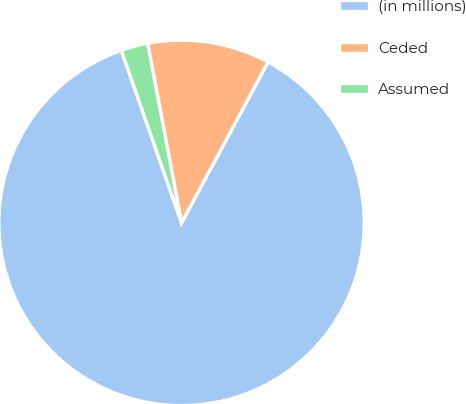Convert chart. <chart><loc_0><loc_0><loc_500><loc_500><pie_chart><fcel>(in millions)<fcel>Ceded<fcel>Assumed<nl><fcel>86.81%<fcel>10.82%<fcel>2.37%<nl></chart> 